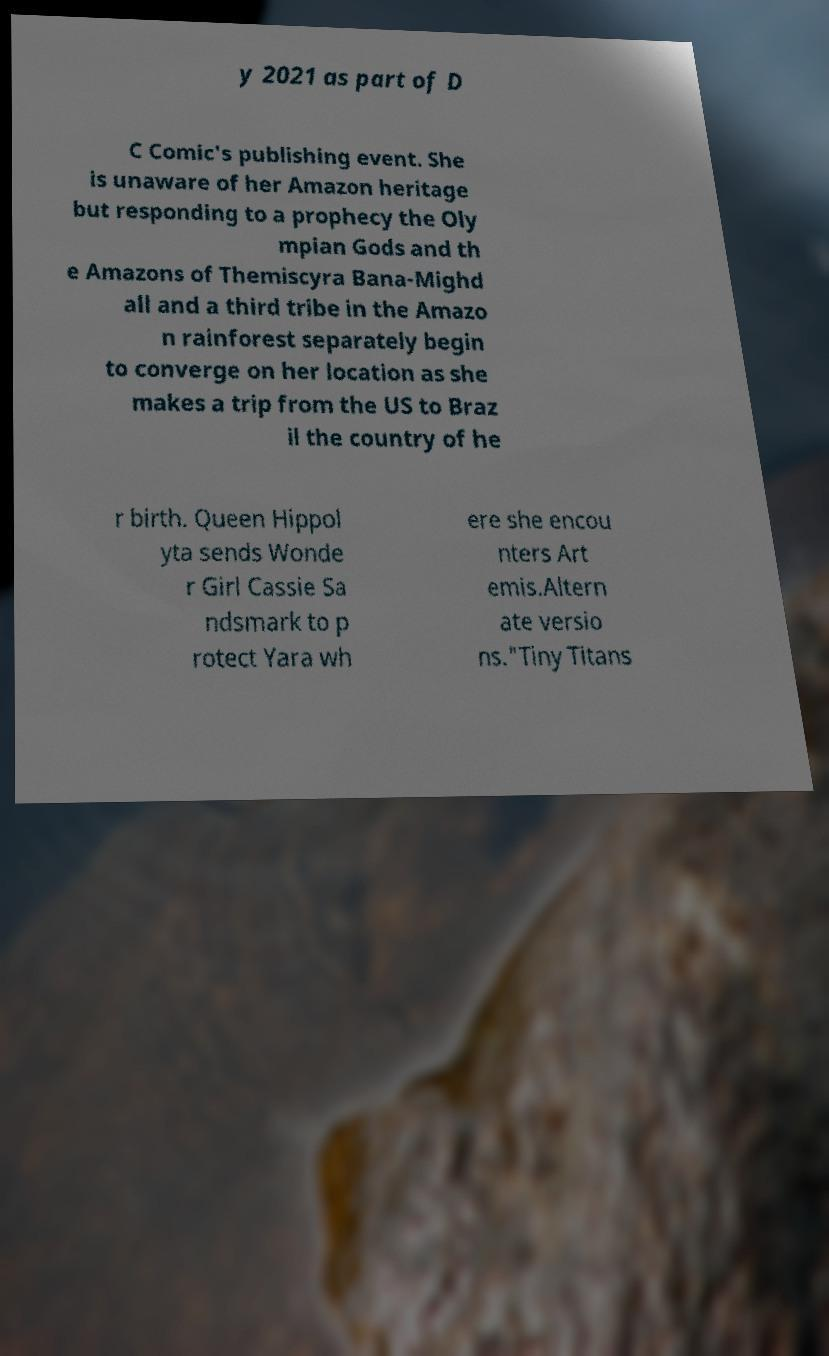Could you extract and type out the text from this image? y 2021 as part of D C Comic's publishing event. She is unaware of her Amazon heritage but responding to a prophecy the Oly mpian Gods and th e Amazons of Themiscyra Bana-Mighd all and a third tribe in the Amazo n rainforest separately begin to converge on her location as she makes a trip from the US to Braz il the country of he r birth. Queen Hippol yta sends Wonde r Girl Cassie Sa ndsmark to p rotect Yara wh ere she encou nters Art emis.Altern ate versio ns."Tiny Titans 